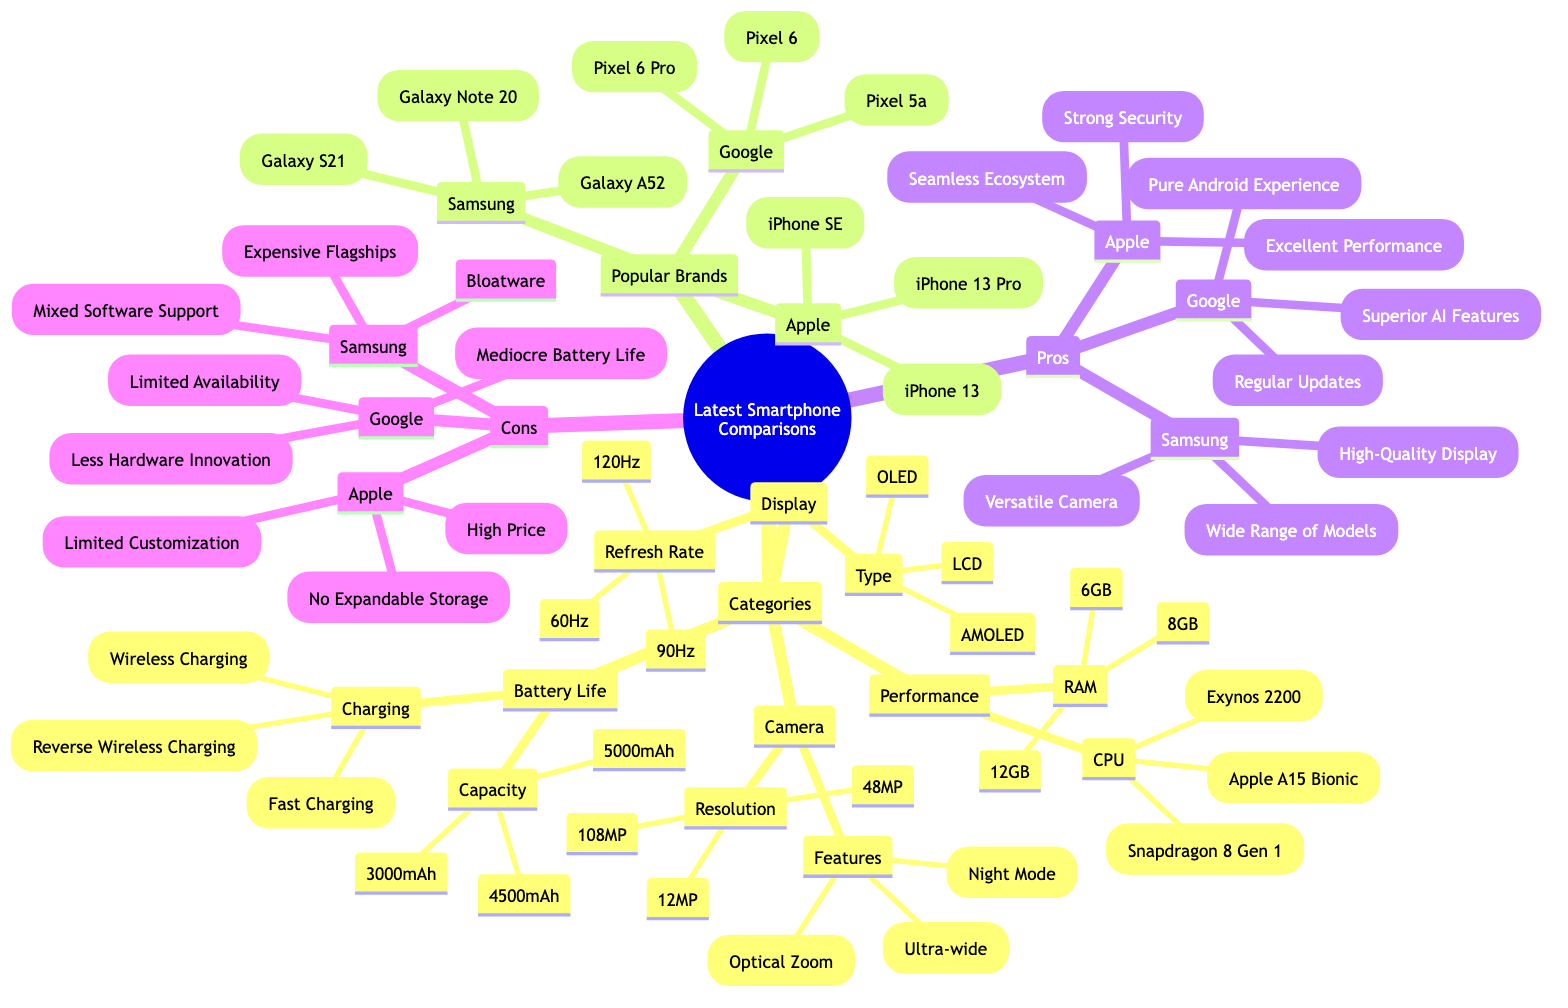What are the CPU options available in the Performance category? The Performance category lists three CPU options: Apple A15 Bionic, Snapdragon 8 Gen 1, and Exynos 2200.
Answer: Apple A15 Bionic, Snapdragon 8 Gen 1, Exynos 2200 How many battery capacity choices are there? Under the Battery Life category, there are three choices listed for capacity: 3000mAh, 4500mAh, and 5000mAh.
Answer: 3 What type of display features an OLED option? The Display category includes display types of AMOLED, LCD, and OLED, thus OLED is included as one of the options.
Answer: OLED Which smartphone brand has the model "Galaxy S21"? "Galaxy S21" is listed under the Samsung brand category, indicating it is a Samsung smartphone model.
Answer: Samsung What is a common con associated with the Google brand? The cons for Google include Limited Availability, Mediocre Battery Life, and Less Hardware Innovation. Therefore, a common con is Limited Availability.
Answer: Limited Availability What are the pros of Apple smartphones? The pros for Apple include Seamless Ecosystem, Excellent Performance, and Strong Security, indicating multiple benefits associated with Apple smartphones.
Answer: Seamless Ecosystem, Excellent Performance, Strong Security Which smartphone has the highest camera resolution listed? The Camera category indicates the highest resolution option available is 108MP, associated with certain smartphones possibly.
Answer: 108MP What charging feature is common in the Battery Life category? The Battery Life category mentions three charging features: Fast Charging, Wireless Charging, and Reverse Wireless Charging, indicating different types of charging technologies available.
Answer: Fast Charging, Wireless Charging, Reverse Wireless Charging Which display refresh rate is the highest available? Among the Refresh Rate options listed, 60Hz, 90Hz, and 120Hz, the highest available refresh rate is 120Hz.
Answer: 120Hz 